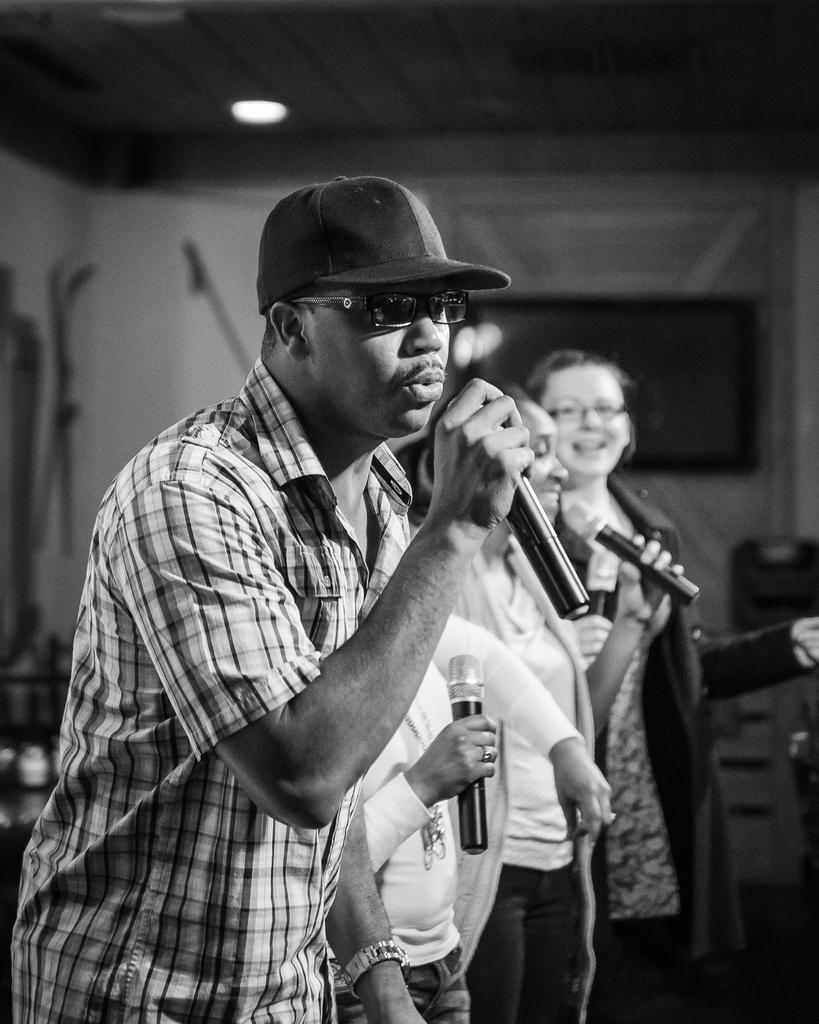What is the color scheme of the image? The image is black and white. How many people are present in the image? There are three people in the image. What are the people holding in their hands? The people are holding microphones. What is one person doing in the image? One man is singing in front of a microphone. Can you describe the background of the image? The background is blurred. What type of drink is being passed around in the image? There is no drink present in the image; it features three people holding microphones. Can you describe the stretching exercises being performed by the people in the image? There are no stretching exercises being performed in the image; the people are holding microphones and one is singing. 